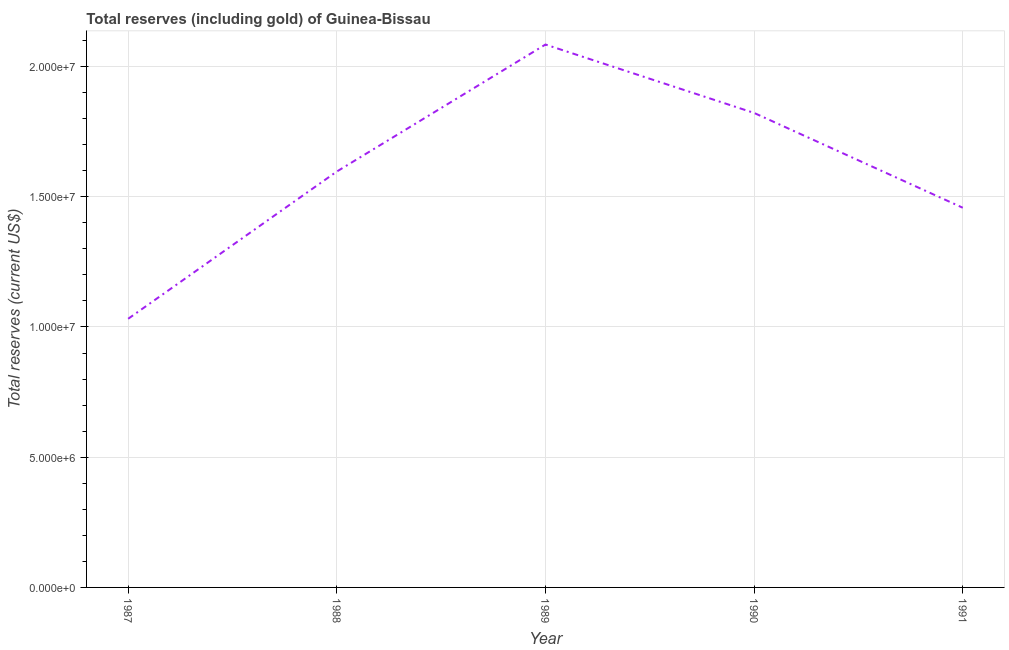What is the total reserves (including gold) in 1990?
Your answer should be very brief. 1.82e+07. Across all years, what is the maximum total reserves (including gold)?
Provide a succinct answer. 2.08e+07. Across all years, what is the minimum total reserves (including gold)?
Make the answer very short. 1.03e+07. In which year was the total reserves (including gold) maximum?
Give a very brief answer. 1989. What is the sum of the total reserves (including gold)?
Give a very brief answer. 7.99e+07. What is the difference between the total reserves (including gold) in 1987 and 1988?
Offer a very short reply. -5.65e+06. What is the average total reserves (including gold) per year?
Keep it short and to the point. 1.60e+07. What is the median total reserves (including gold)?
Make the answer very short. 1.60e+07. In how many years, is the total reserves (including gold) greater than 11000000 US$?
Your response must be concise. 4. Do a majority of the years between 1990 and 1991 (inclusive) have total reserves (including gold) greater than 12000000 US$?
Your response must be concise. Yes. What is the ratio of the total reserves (including gold) in 1989 to that in 1991?
Your answer should be very brief. 1.43. Is the difference between the total reserves (including gold) in 1988 and 1991 greater than the difference between any two years?
Provide a succinct answer. No. What is the difference between the highest and the second highest total reserves (including gold)?
Provide a succinct answer. 2.63e+06. Is the sum of the total reserves (including gold) in 1987 and 1990 greater than the maximum total reserves (including gold) across all years?
Your answer should be very brief. Yes. What is the difference between the highest and the lowest total reserves (including gold)?
Offer a terse response. 1.05e+07. In how many years, is the total reserves (including gold) greater than the average total reserves (including gold) taken over all years?
Make the answer very short. 2. How many years are there in the graph?
Ensure brevity in your answer.  5. What is the difference between two consecutive major ticks on the Y-axis?
Provide a succinct answer. 5.00e+06. Does the graph contain any zero values?
Provide a short and direct response. No. What is the title of the graph?
Offer a very short reply. Total reserves (including gold) of Guinea-Bissau. What is the label or title of the Y-axis?
Make the answer very short. Total reserves (current US$). What is the Total reserves (current US$) of 1987?
Ensure brevity in your answer.  1.03e+07. What is the Total reserves (current US$) of 1988?
Offer a terse response. 1.60e+07. What is the Total reserves (current US$) of 1989?
Provide a short and direct response. 2.08e+07. What is the Total reserves (current US$) of 1990?
Your answer should be compact. 1.82e+07. What is the Total reserves (current US$) of 1991?
Offer a very short reply. 1.46e+07. What is the difference between the Total reserves (current US$) in 1987 and 1988?
Your answer should be compact. -5.65e+06. What is the difference between the Total reserves (current US$) in 1987 and 1989?
Provide a short and direct response. -1.05e+07. What is the difference between the Total reserves (current US$) in 1987 and 1990?
Keep it short and to the point. -7.90e+06. What is the difference between the Total reserves (current US$) in 1987 and 1991?
Ensure brevity in your answer.  -4.26e+06. What is the difference between the Total reserves (current US$) in 1988 and 1989?
Offer a very short reply. -4.88e+06. What is the difference between the Total reserves (current US$) in 1988 and 1990?
Offer a terse response. -2.25e+06. What is the difference between the Total reserves (current US$) in 1988 and 1991?
Your response must be concise. 1.39e+06. What is the difference between the Total reserves (current US$) in 1989 and 1990?
Provide a succinct answer. 2.63e+06. What is the difference between the Total reserves (current US$) in 1989 and 1991?
Provide a short and direct response. 6.27e+06. What is the difference between the Total reserves (current US$) in 1990 and 1991?
Offer a terse response. 3.64e+06. What is the ratio of the Total reserves (current US$) in 1987 to that in 1988?
Provide a succinct answer. 0.65. What is the ratio of the Total reserves (current US$) in 1987 to that in 1989?
Provide a short and direct response. 0.49. What is the ratio of the Total reserves (current US$) in 1987 to that in 1990?
Ensure brevity in your answer.  0.57. What is the ratio of the Total reserves (current US$) in 1987 to that in 1991?
Your answer should be compact. 0.71. What is the ratio of the Total reserves (current US$) in 1988 to that in 1989?
Offer a terse response. 0.77. What is the ratio of the Total reserves (current US$) in 1988 to that in 1990?
Offer a terse response. 0.88. What is the ratio of the Total reserves (current US$) in 1988 to that in 1991?
Make the answer very short. 1.09. What is the ratio of the Total reserves (current US$) in 1989 to that in 1990?
Provide a succinct answer. 1.14. What is the ratio of the Total reserves (current US$) in 1989 to that in 1991?
Your response must be concise. 1.43. 